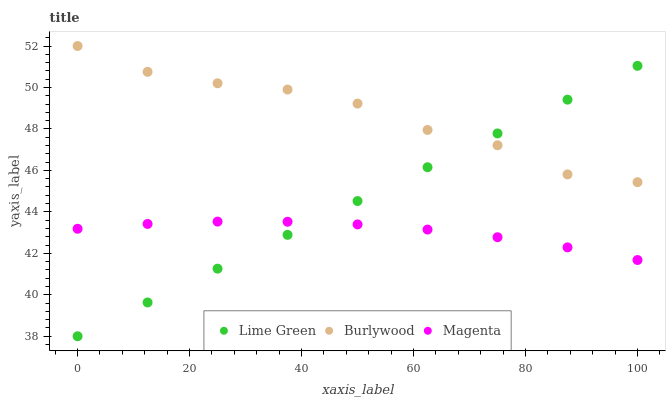Does Magenta have the minimum area under the curve?
Answer yes or no. Yes. Does Burlywood have the maximum area under the curve?
Answer yes or no. Yes. Does Lime Green have the minimum area under the curve?
Answer yes or no. No. Does Lime Green have the maximum area under the curve?
Answer yes or no. No. Is Lime Green the smoothest?
Answer yes or no. Yes. Is Burlywood the roughest?
Answer yes or no. Yes. Is Magenta the smoothest?
Answer yes or no. No. Is Magenta the roughest?
Answer yes or no. No. Does Lime Green have the lowest value?
Answer yes or no. Yes. Does Magenta have the lowest value?
Answer yes or no. No. Does Burlywood have the highest value?
Answer yes or no. Yes. Does Lime Green have the highest value?
Answer yes or no. No. Is Magenta less than Burlywood?
Answer yes or no. Yes. Is Burlywood greater than Magenta?
Answer yes or no. Yes. Does Lime Green intersect Magenta?
Answer yes or no. Yes. Is Lime Green less than Magenta?
Answer yes or no. No. Is Lime Green greater than Magenta?
Answer yes or no. No. Does Magenta intersect Burlywood?
Answer yes or no. No. 